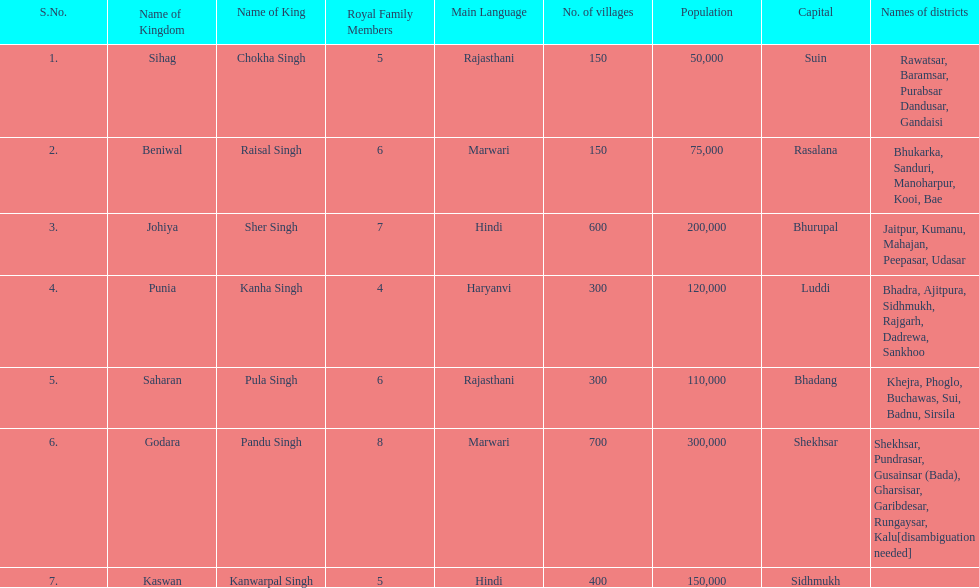How many realms are listed? 7. 